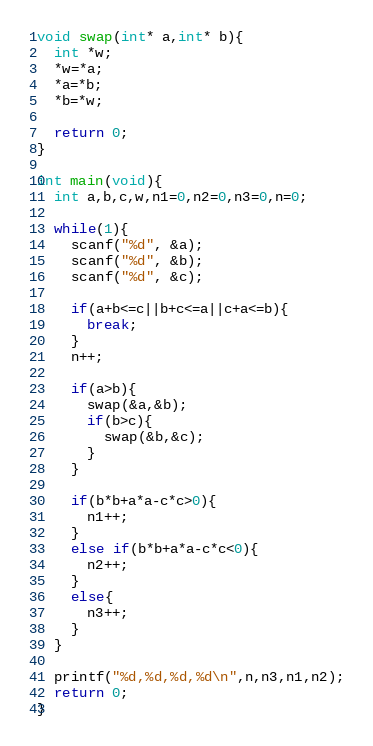Convert code to text. <code><loc_0><loc_0><loc_500><loc_500><_C_>void swap(int* a,int* b){
  int *w;
  *w=*a;
  *a=*b;
  *b=*w;

  return 0;
}

int main(void){
  int a,b,c,w,n1=0,n2=0,n3=0,n=0;

  while(1){
    scanf("%d", &a);
    scanf("%d", &b);
    scanf("%d", &c);

    if(a+b<=c||b+c<=a||c+a<=b){
      break;
    }
    n++;

    if(a>b){
      swap(&a,&b);
      if(b>c){
        swap(&b,&c);
      }
    }

    if(b*b+a*a-c*c>0){
      n1++;
    }
    else if(b*b+a*a-c*c<0){
      n2++;
    }
    else{
      n3++;
    }
  }

  printf("%d,%d,%d,%d\n",n,n3,n1,n2);
  return 0;
}

</code> 